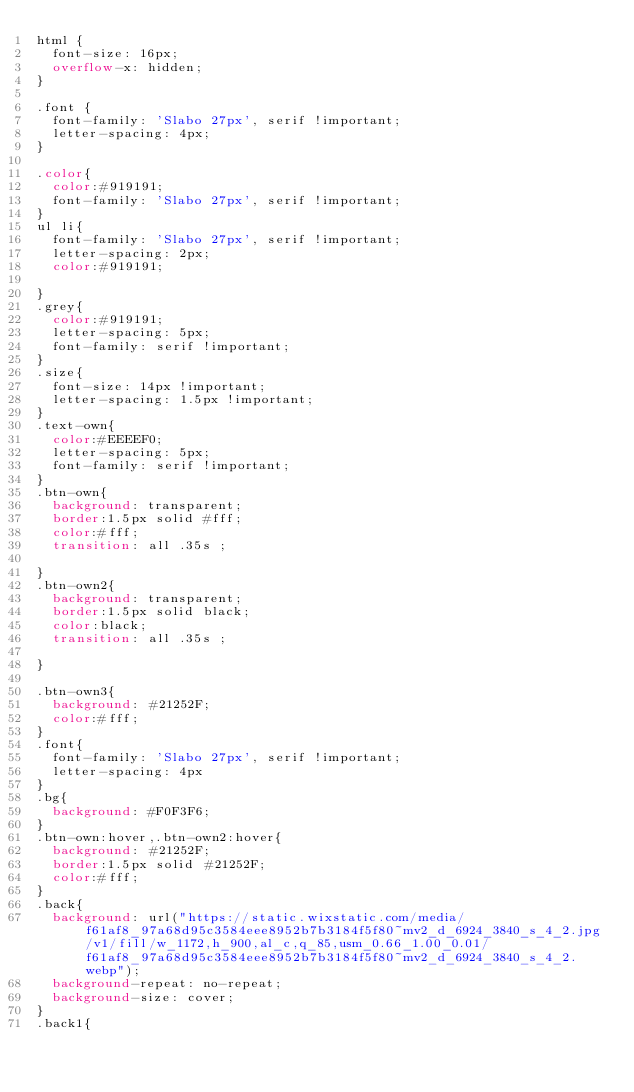<code> <loc_0><loc_0><loc_500><loc_500><_CSS_>html {
  font-size: 16px;
  overflow-x: hidden;
}

.font {
  font-family: 'Slabo 27px', serif !important;
  letter-spacing: 4px;
}

.color{
  color:#919191;
  font-family: 'Slabo 27px', serif !important;
}
ul li{
  font-family: 'Slabo 27px', serif !important;
  letter-spacing: 2px;
  color:#919191;
  
}
.grey{
  color:#919191;
  letter-spacing: 5px;
  font-family: serif !important;
}
.size{
  font-size: 14px !important;
  letter-spacing: 1.5px !important;
}
.text-own{
  color:#EEEEF0;
  letter-spacing: 5px;
  font-family: serif !important;
}
.btn-own{
  background: transparent;
  border:1.5px solid #fff;
  color:#fff;
  transition: all .35s ;

}
.btn-own2{
  background: transparent;
  border:1.5px solid black;
  color:black;
  transition: all .35s ;

}

.btn-own3{
  background: #21252F;
  color:#fff;
}
.font{
  font-family: 'Slabo 27px', serif !important;
  letter-spacing: 4px
}
.bg{
  background: #F0F3F6;
}
.btn-own:hover,.btn-own2:hover{
  background: #21252F;
  border:1.5px solid #21252F;
  color:#fff;
}
.back{
  background: url("https://static.wixstatic.com/media/f61af8_97a68d95c3584eee8952b7b3184f5f80~mv2_d_6924_3840_s_4_2.jpg/v1/fill/w_1172,h_900,al_c,q_85,usm_0.66_1.00_0.01/f61af8_97a68d95c3584eee8952b7b3184f5f80~mv2_d_6924_3840_s_4_2.webp");
  background-repeat: no-repeat;
  background-size: cover;
}
.back1{</code> 